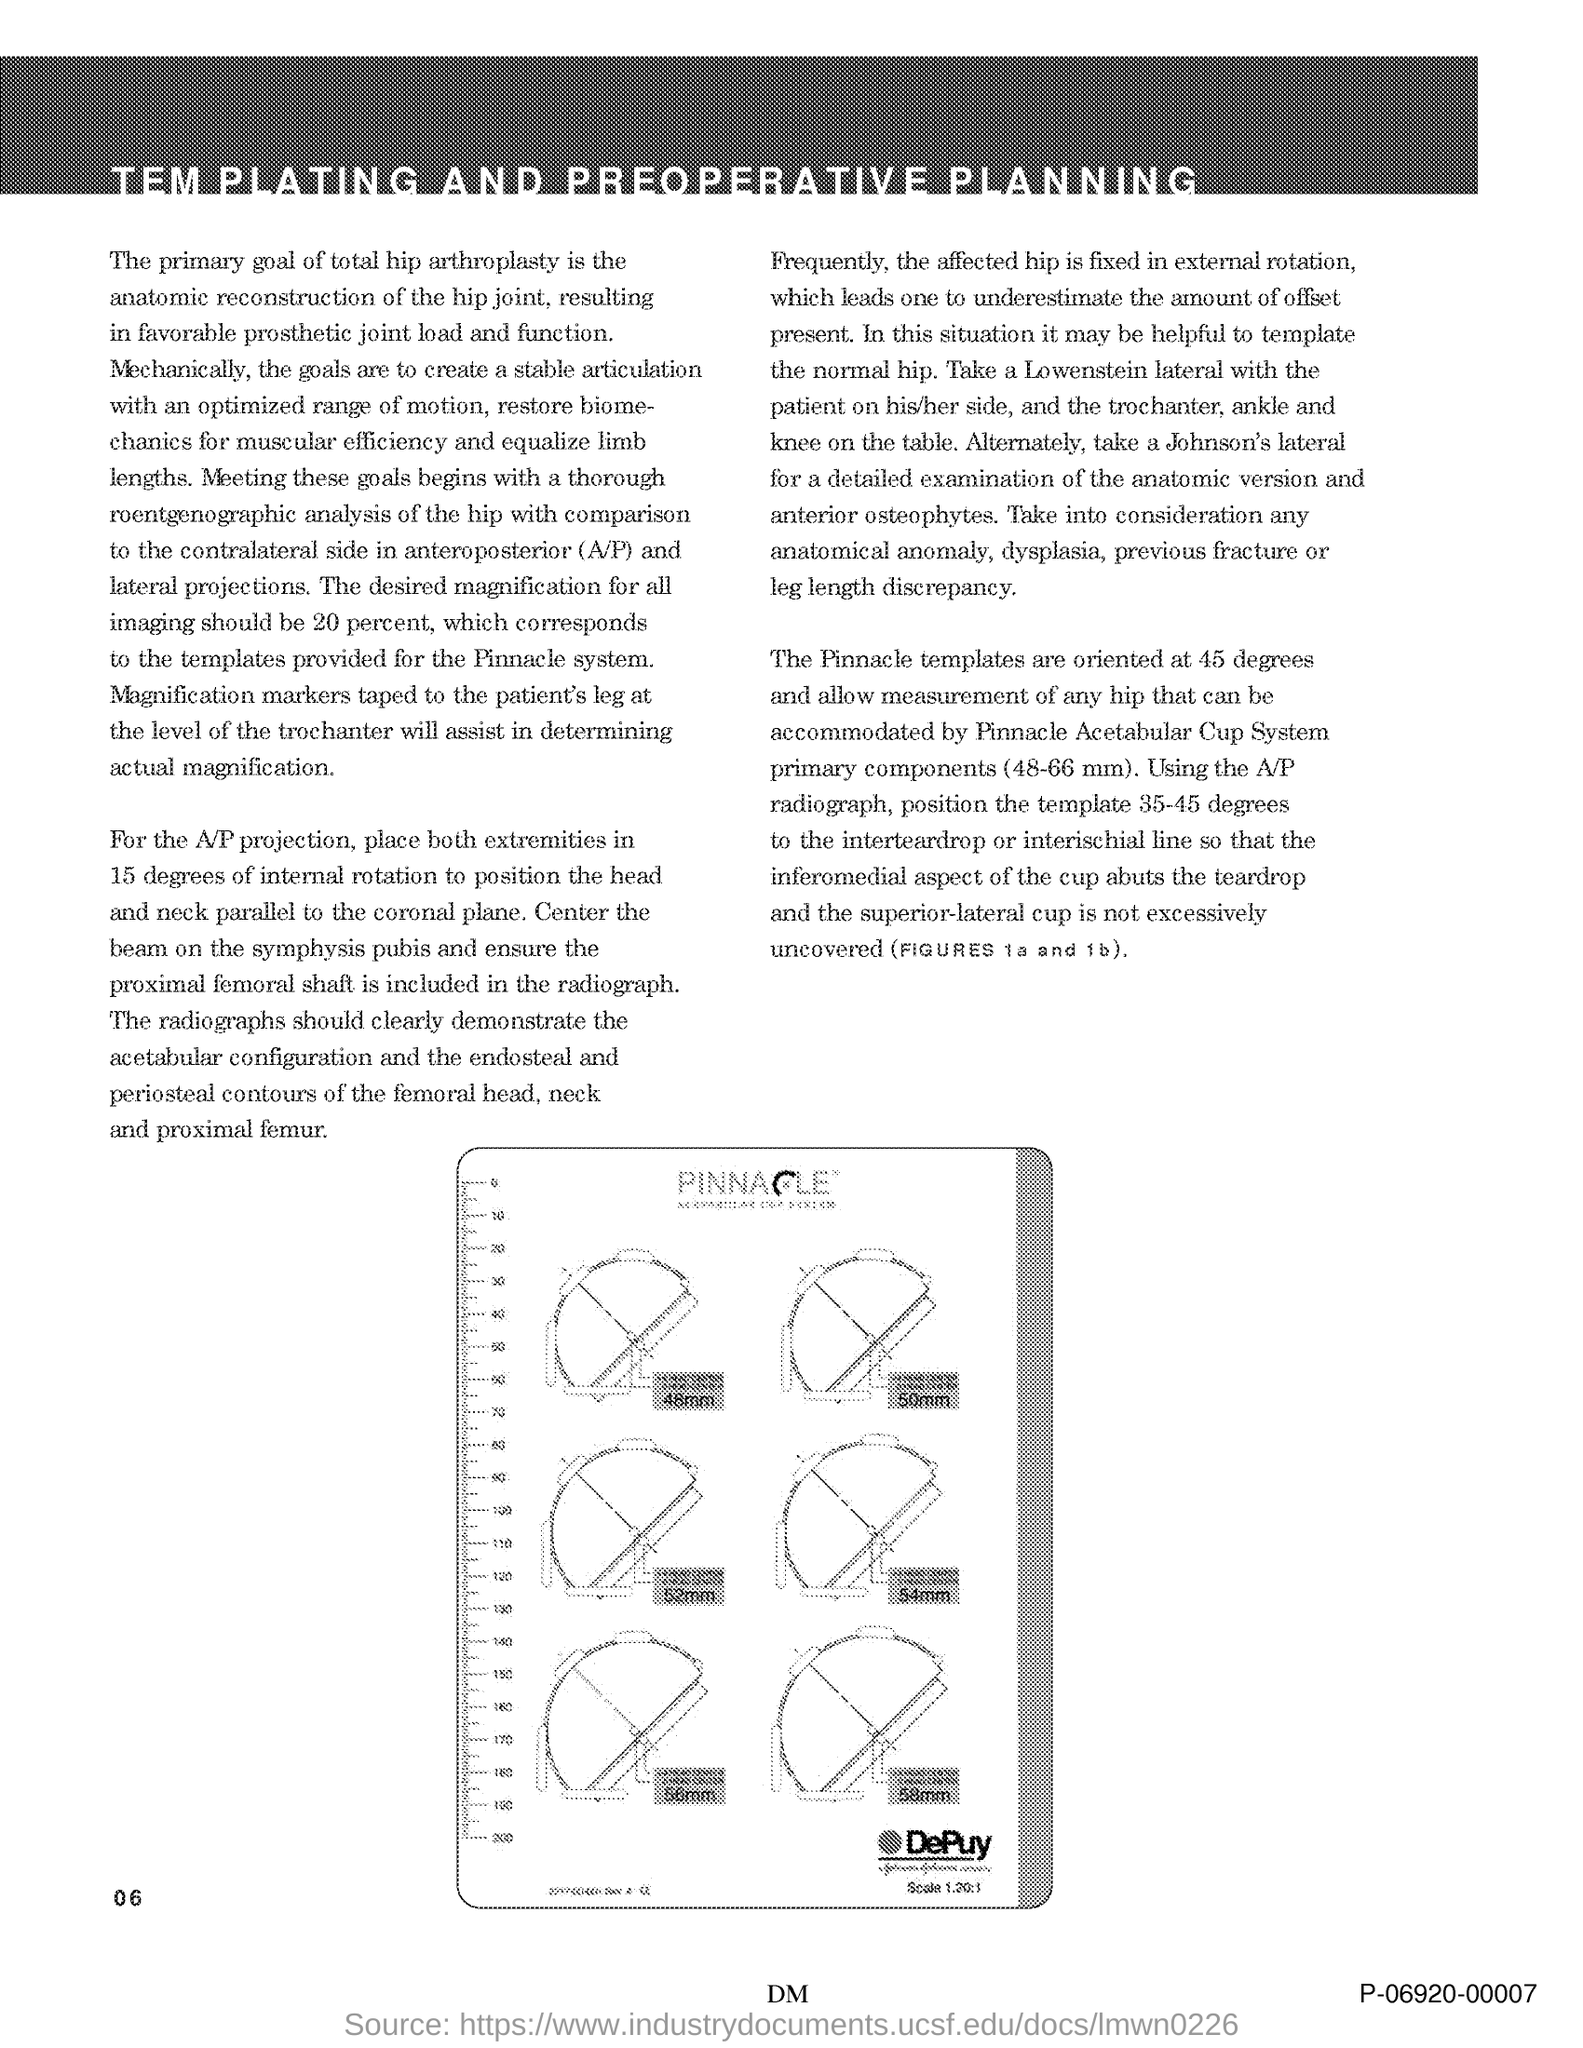At what degree the Pinnacle templates is oriented?
Your answer should be compact. 45 degrees. What clearly demonstrates the acetabular configuration?
Your answer should be compact. The radiographs. 